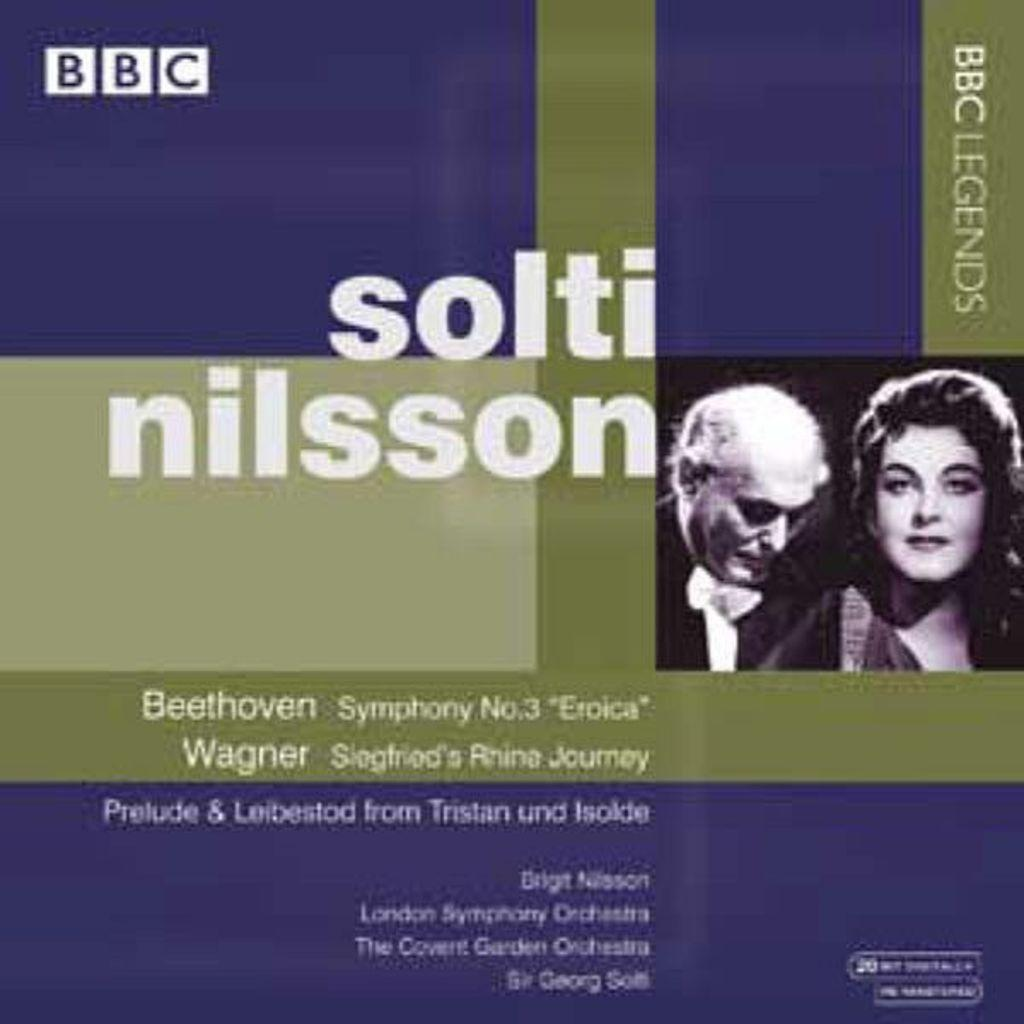What is the main subject in the center of the image? There is a poster in the center of the image. What is depicted on the poster? There are two persons depicted on the poster. Is there any text on the poster? Yes, there is writing on the poster. What grade did the person on the left receive on their report card in the image? There is no report card or grade mentioned in the image; it only features a poster with two persons and writing. What type of toys are visible in the image? There are no toys present in the image; it only features a poster with two persons and writing. 